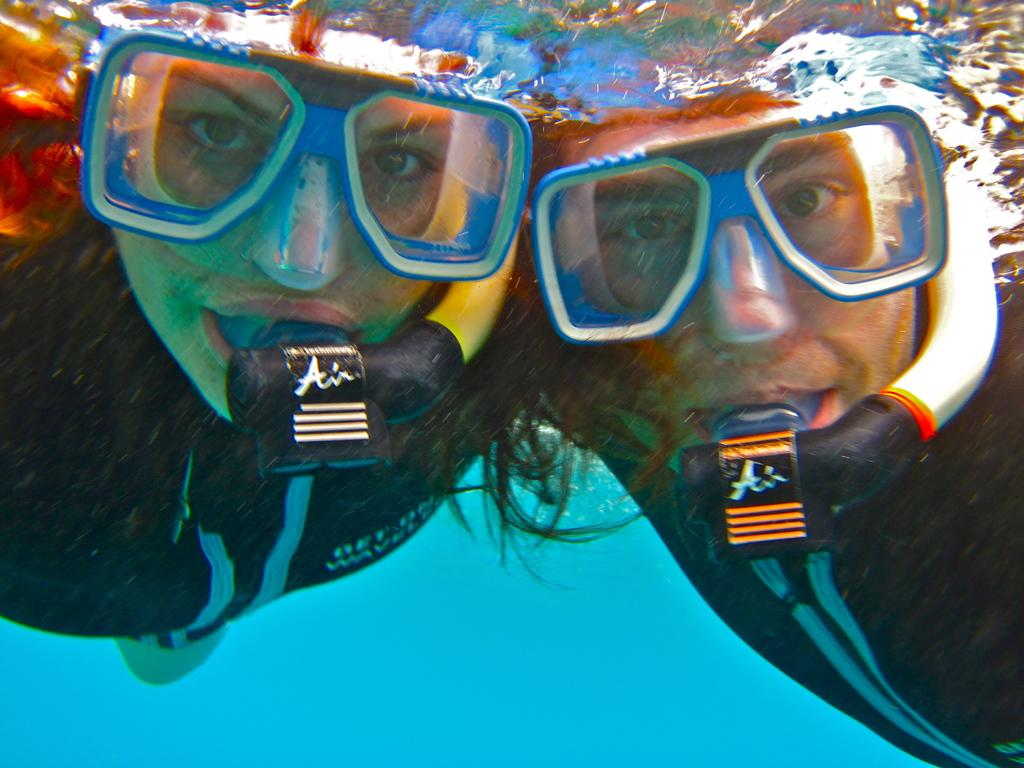What are the two people in the image doing? The man and woman are in the water in the image. What are they wearing while in the water? They are wearing some objects, which could be swimsuits or other water-related attire. What color is the background of the image? The background of the image is blue in color. What route are the people taking to dispose of their waste in the image? There is no mention of waste or a route in the image; it simply shows two people in the water. 